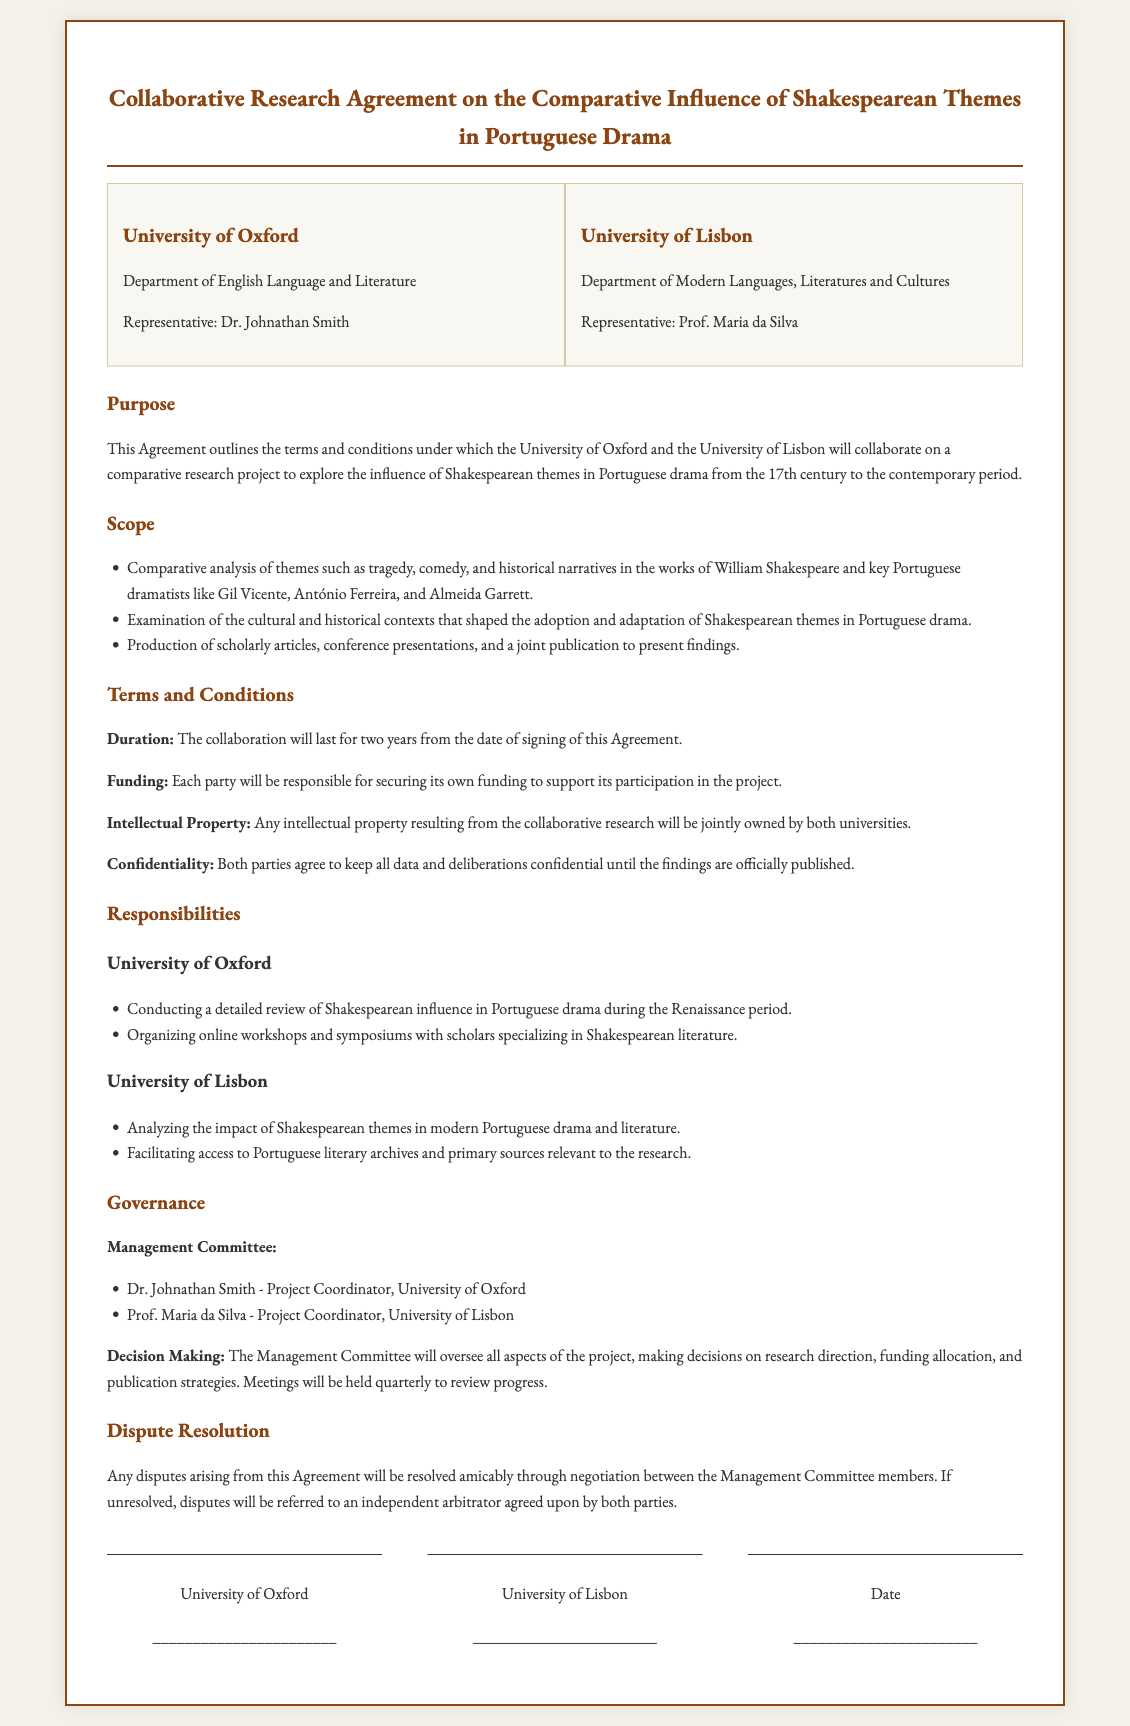What is the title of the agreement? The title of the agreement is stated at the beginning of the document and encapsulates the essence of the collaboration.
Answer: Collaborative Research Agreement on the Comparative Influence of Shakespearean Themes in Portuguese Drama Who represents the University of Oxford? The document mentions the representative of the University of Oxford, indicating their role in the collaboration.
Answer: Dr. Johnathan Smith What is the duration of the collaboration? The duration of the collaboration is specified in the terms and conditions section of the document.
Answer: Two years Which themes will be analyzed in the project? The scope section lists the themes that will be a central part of the research analysis.
Answer: Tragedy, comedy, and historical narratives Who is responsible for analyzing modern Portuguese drama? The responsibilities section specifies which university takes on the task of analyzing modern Portuguese drama.
Answer: University of Lisbon What are the two universities involved in the agreement? The document explicitly names both educational institutions participating in this research collaboration.
Answer: University of Oxford and University of Lisbon What will the Management Committee oversee? The governance section mentions the areas that the Management Committee will be responsible for during the project.
Answer: All aspects of the project How will disputes be resolved according to the agreement? The dispute resolution section outlines the process for handling disagreements that may arise during the collaboration.
Answer: Negotiation and independent arbitrator 